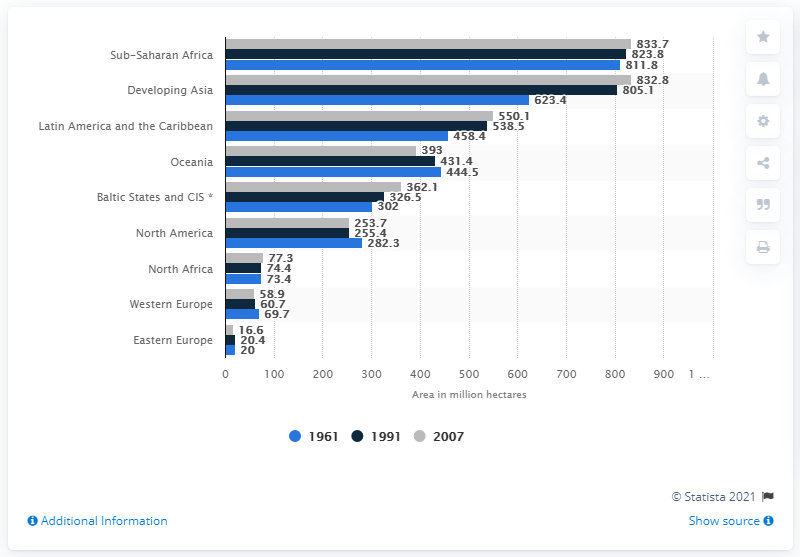Mention a couple of crucial points in this snapshot. In 1961, approximately 302 hectares of grazing land was available in the Baltic States and the Commonwealth of Independent States. 